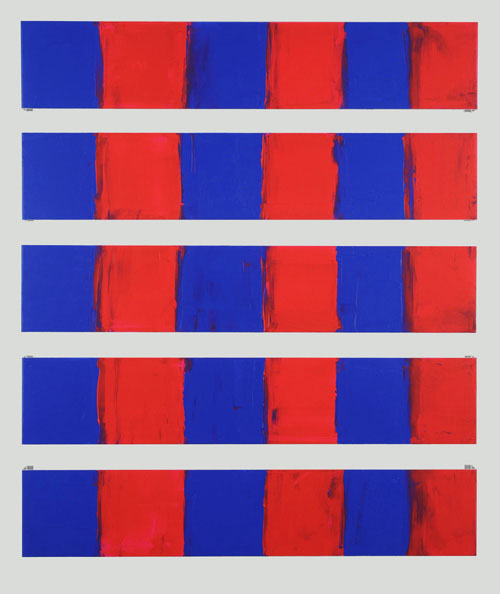What might be the artist's intention behind using these specific colors and arrangement? The artist's intention behind using red and blue in this manner could be to explore the dynamic interplay between two powerful colors that often symbolize contrasting emotions or states. Red, often associated with passion, energy, and danger, contrasts with blue, which symbolizes calmness, stability, and melancholy. By layering red over blue, the artist may be expressing a narrative of how intense emotions can overlay a stable foundation or vice versa. The grid-like arrangement of the panels could further emphasize themes of structure and chaos, suggesting a balance or conflict between the two. Can you connect this artwork to any historical art movements? This artwork can be closely linked to the Color Field Painting movement, which emerged in the mid-20th century. Artists like Mark Rothko and Barnett Newman were prominent figures in this movement, focusing on large areas of a single color to evoke an emotional response from the viewer. The balance and symmetry we see in these panels also echo the minimalist movement, which sought to reduce art to its most essential elements. The interplay between the colors and their application over each other might also remind one of Abstract Expressionism, where the process and physical act of painting were intrinsic to the final piece. 